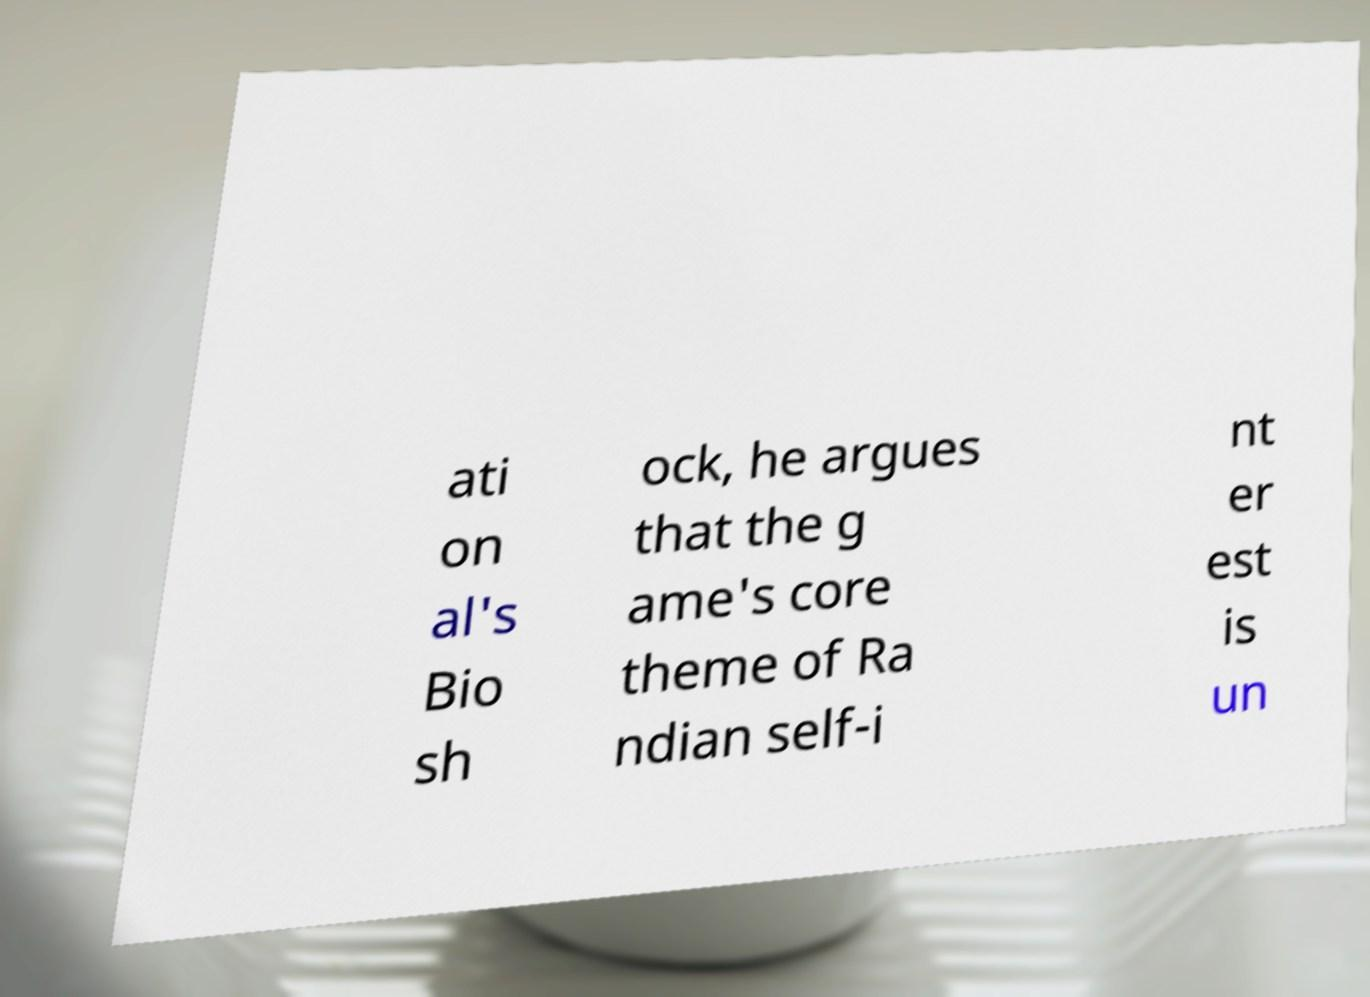Could you assist in decoding the text presented in this image and type it out clearly? ati on al's Bio sh ock, he argues that the g ame's core theme of Ra ndian self-i nt er est is un 